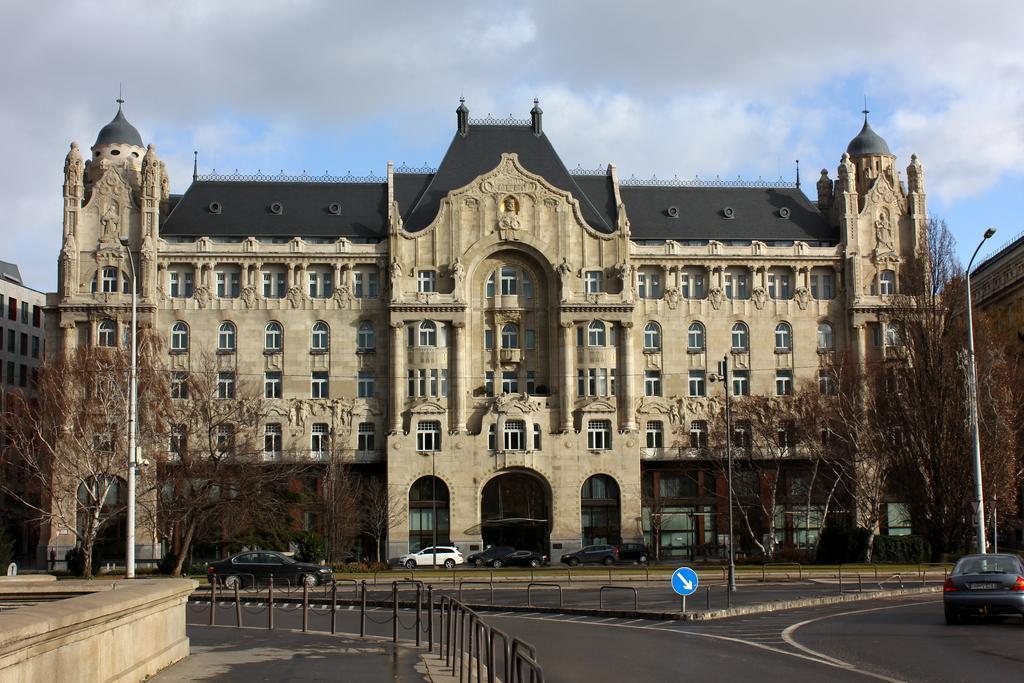Please provide a concise description of this image. In this image we can see the buildings, trees, light poles. We can also see the vehicles passing on the road. There are barriers and some direction board. At the top there is sky with the clouds. 